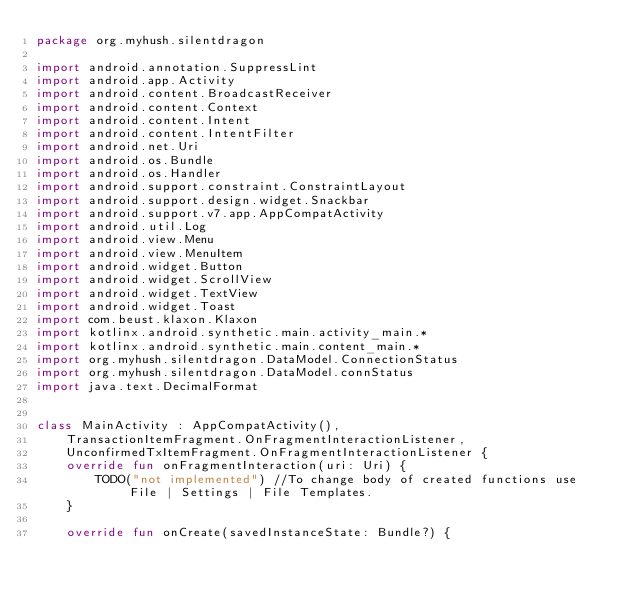<code> <loc_0><loc_0><loc_500><loc_500><_Kotlin_>package org.myhush.silentdragon

import android.annotation.SuppressLint
import android.app.Activity
import android.content.BroadcastReceiver
import android.content.Context
import android.content.Intent
import android.content.IntentFilter
import android.net.Uri
import android.os.Bundle
import android.os.Handler
import android.support.constraint.ConstraintLayout
import android.support.design.widget.Snackbar
import android.support.v7.app.AppCompatActivity
import android.util.Log
import android.view.Menu
import android.view.MenuItem
import android.widget.Button
import android.widget.ScrollView
import android.widget.TextView
import android.widget.Toast
import com.beust.klaxon.Klaxon
import kotlinx.android.synthetic.main.activity_main.*
import kotlinx.android.synthetic.main.content_main.*
import org.myhush.silentdragon.DataModel.ConnectionStatus
import org.myhush.silentdragon.DataModel.connStatus
import java.text.DecimalFormat


class MainActivity : AppCompatActivity(),
    TransactionItemFragment.OnFragmentInteractionListener,
    UnconfirmedTxItemFragment.OnFragmentInteractionListener {
    override fun onFragmentInteraction(uri: Uri) {
        TODO("not implemented") //To change body of created functions use File | Settings | File Templates.
    }

    override fun onCreate(savedInstanceState: Bundle?) {</code> 